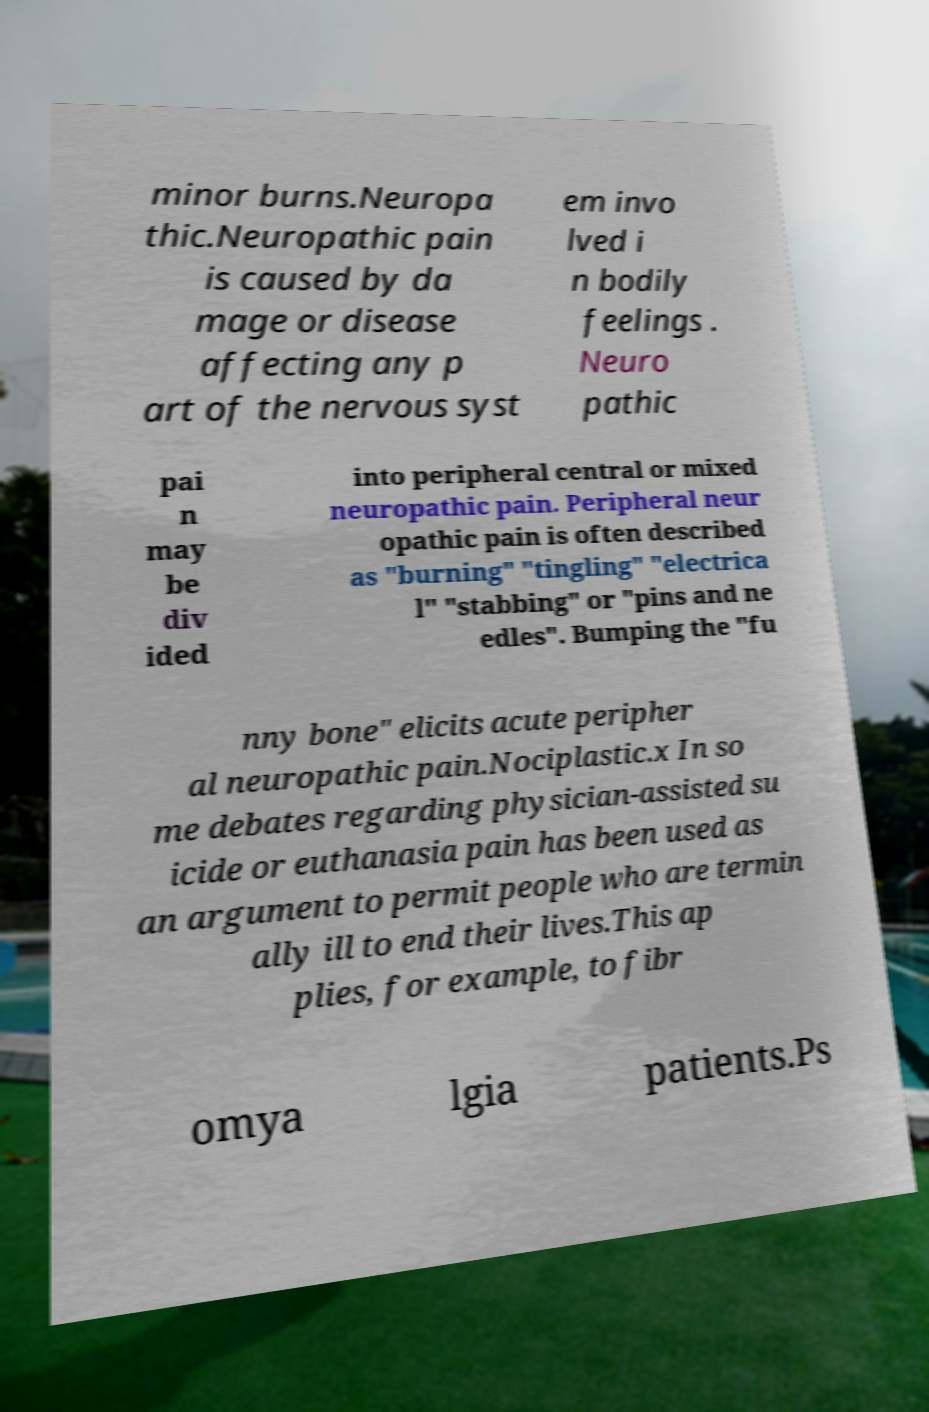Can you accurately transcribe the text from the provided image for me? minor burns.Neuropa thic.Neuropathic pain is caused by da mage or disease affecting any p art of the nervous syst em invo lved i n bodily feelings . Neuro pathic pai n may be div ided into peripheral central or mixed neuropathic pain. Peripheral neur opathic pain is often described as "burning" "tingling" "electrica l" "stabbing" or "pins and ne edles". Bumping the "fu nny bone" elicits acute peripher al neuropathic pain.Nociplastic.x In so me debates regarding physician-assisted su icide or euthanasia pain has been used as an argument to permit people who are termin ally ill to end their lives.This ap plies, for example, to fibr omya lgia patients.Ps 